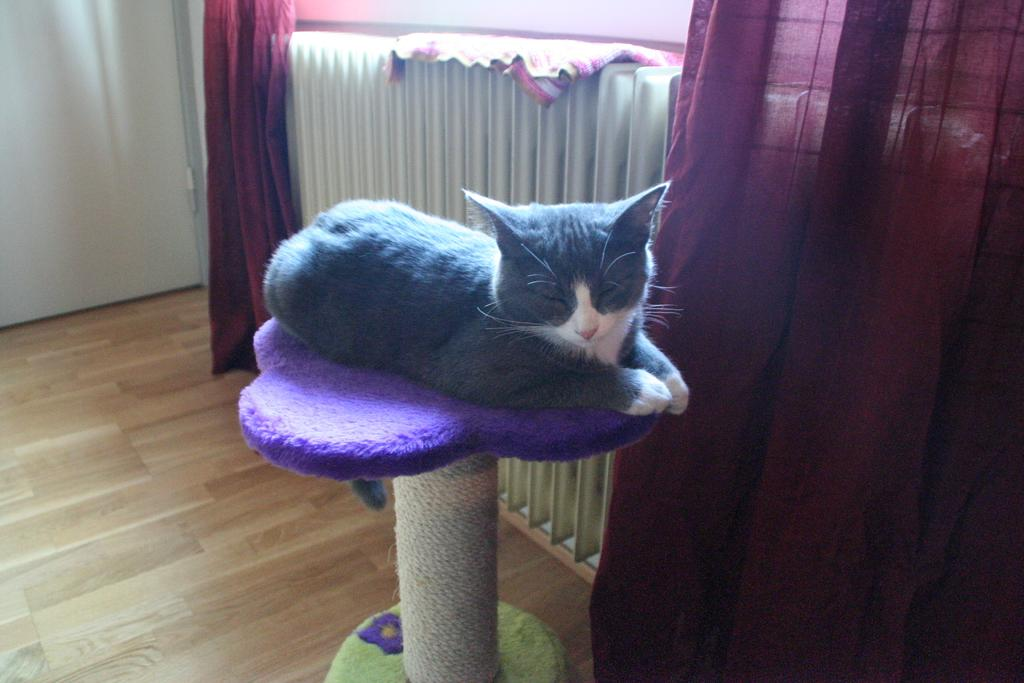What type of animal is in the image? There is a black color cat in the image. Where is the cat located? The cat is on a table. What can be seen in the background of the image? There is a curtain, a door, and a mat in the background of the image. What part of the room is visible at the bottom of the image? The floor is visible at the bottom of the image. What type of songs is the cat singing in the image? There is no indication in the image that the cat is singing any songs. 